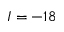<formula> <loc_0><loc_0><loc_500><loc_500>I = - 1 8</formula> 